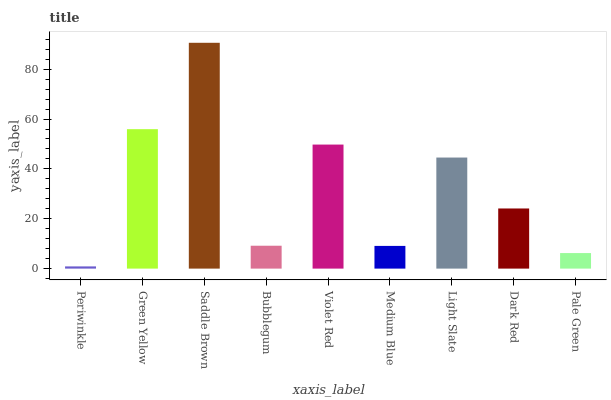Is Periwinkle the minimum?
Answer yes or no. Yes. Is Saddle Brown the maximum?
Answer yes or no. Yes. Is Green Yellow the minimum?
Answer yes or no. No. Is Green Yellow the maximum?
Answer yes or no. No. Is Green Yellow greater than Periwinkle?
Answer yes or no. Yes. Is Periwinkle less than Green Yellow?
Answer yes or no. Yes. Is Periwinkle greater than Green Yellow?
Answer yes or no. No. Is Green Yellow less than Periwinkle?
Answer yes or no. No. Is Dark Red the high median?
Answer yes or no. Yes. Is Dark Red the low median?
Answer yes or no. Yes. Is Light Slate the high median?
Answer yes or no. No. Is Bubblegum the low median?
Answer yes or no. No. 